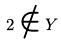Convert formula to latex. <formula><loc_0><loc_0><loc_500><loc_500>2 \notin Y</formula> 